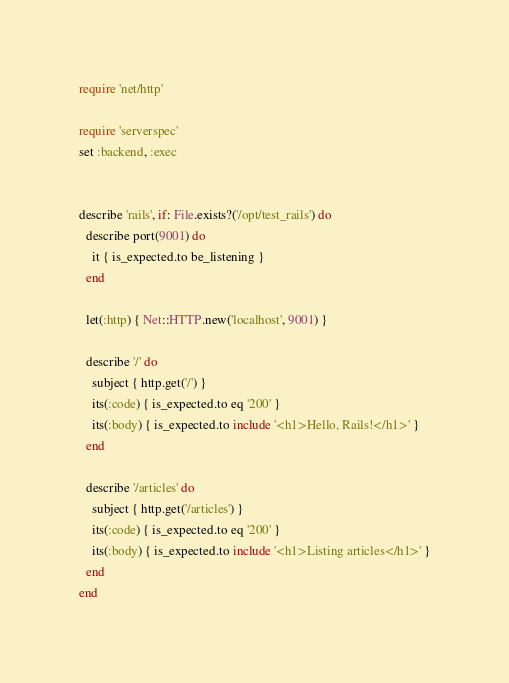<code> <loc_0><loc_0><loc_500><loc_500><_Ruby_>
require 'net/http'

require 'serverspec'
set :backend, :exec


describe 'rails', if: File.exists?('/opt/test_rails') do
  describe port(9001) do
    it { is_expected.to be_listening }
  end

  let(:http) { Net::HTTP.new('localhost', 9001) }

  describe '/' do
    subject { http.get('/') }
    its(:code) { is_expected.to eq '200' }
    its(:body) { is_expected.to include '<h1>Hello, Rails!</h1>' }
  end

  describe '/articles' do
    subject { http.get('/articles') }
    its(:code) { is_expected.to eq '200' }
    its(:body) { is_expected.to include '<h1>Listing articles</h1>' }
  end
end
</code> 